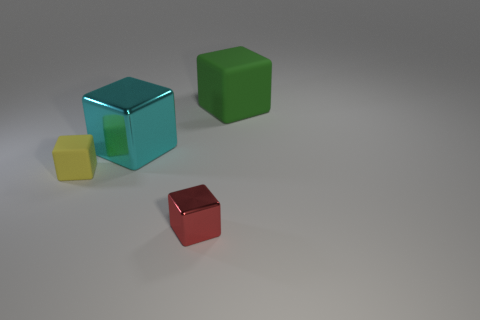Add 1 big gray cylinders. How many objects exist? 5 Subtract all yellow rubber blocks. Subtract all large purple matte cylinders. How many objects are left? 3 Add 3 tiny red metal things. How many tiny red metal things are left? 4 Add 2 green blocks. How many green blocks exist? 3 Subtract all red blocks. How many blocks are left? 3 Subtract all small red shiny blocks. How many blocks are left? 3 Subtract 0 yellow spheres. How many objects are left? 4 Subtract 2 blocks. How many blocks are left? 2 Subtract all brown cubes. Subtract all brown spheres. How many cubes are left? 4 Subtract all purple balls. How many yellow blocks are left? 1 